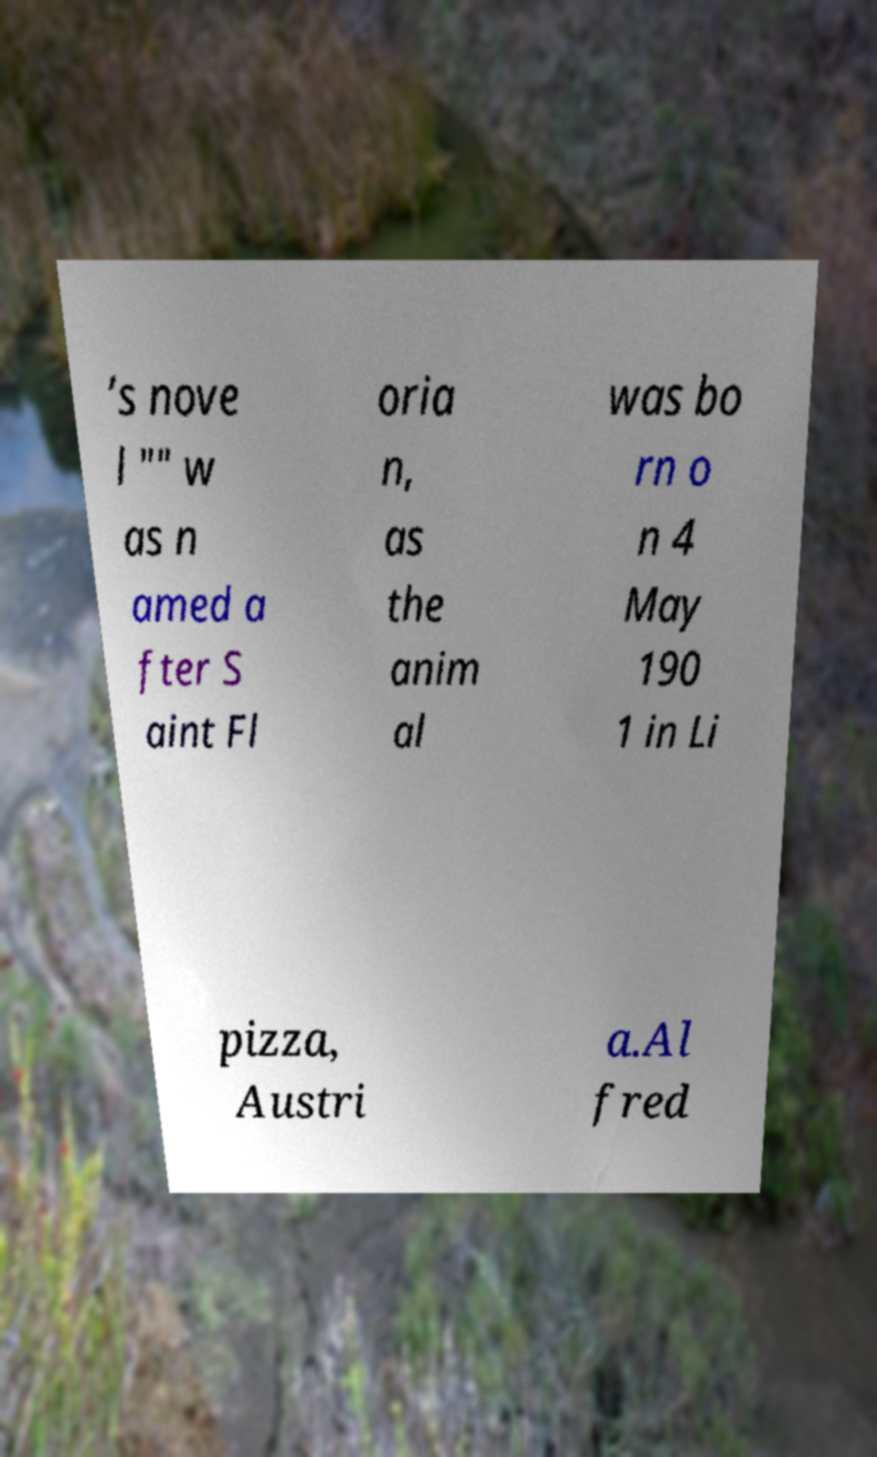Please identify and transcribe the text found in this image. ’s nove l "" w as n amed a fter S aint Fl oria n, as the anim al was bo rn o n 4 May 190 1 in Li pizza, Austri a.Al fred 